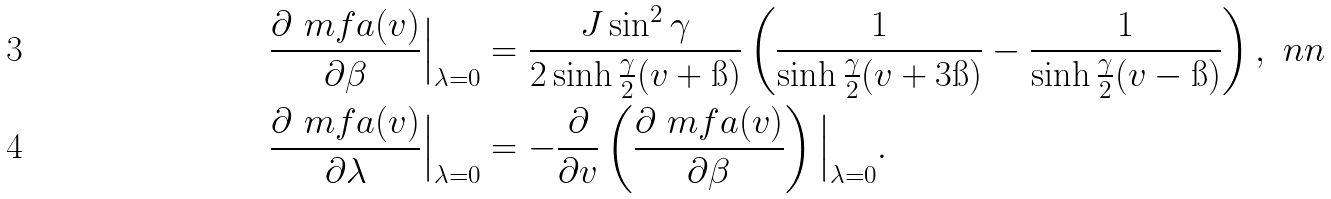<formula> <loc_0><loc_0><loc_500><loc_500>\frac { \partial \ m f a ( v ) } { \partial \beta } \Big | _ { \lambda = 0 } & = \frac { J \sin ^ { 2 } \gamma } { 2 \sinh \frac { \gamma } { 2 } ( v + \i ) } \left ( \frac { 1 } { \sinh \frac { \gamma } { 2 } ( v + 3 \i ) } - \frac { 1 } { \sinh \frac { \gamma } { 2 } ( v - \i ) } \right ) , \ n n \\ \frac { \partial \ m f a ( v ) } { \partial \lambda } \Big | _ { \lambda = 0 } & = - \frac { \partial } { \partial v } \left ( \frac { \partial \ m f a ( v ) } { \partial \beta } \right ) \Big | _ { \lambda = 0 } .</formula> 